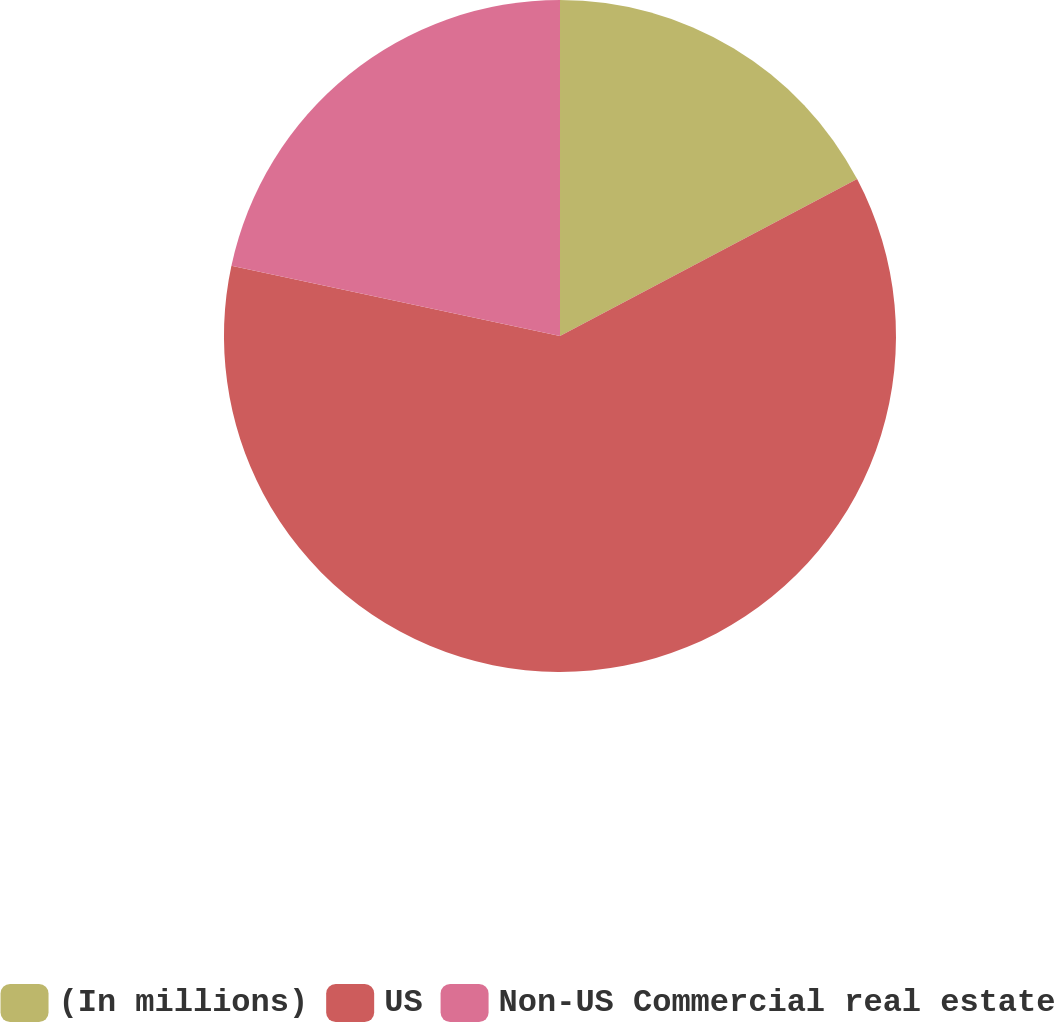<chart> <loc_0><loc_0><loc_500><loc_500><pie_chart><fcel>(In millions)<fcel>US<fcel>Non-US Commercial real estate<nl><fcel>17.27%<fcel>61.09%<fcel>21.65%<nl></chart> 